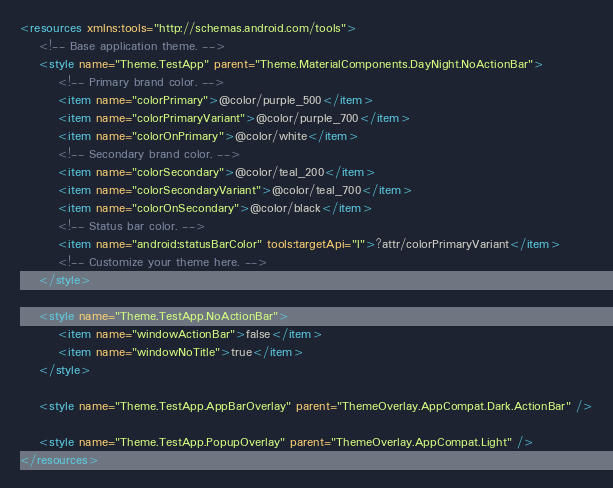<code> <loc_0><loc_0><loc_500><loc_500><_XML_><resources xmlns:tools="http://schemas.android.com/tools">
    <!-- Base application theme. -->
    <style name="Theme.TestApp" parent="Theme.MaterialComponents.DayNight.NoActionBar">
        <!-- Primary brand color. -->
        <item name="colorPrimary">@color/purple_500</item>
        <item name="colorPrimaryVariant">@color/purple_700</item>
        <item name="colorOnPrimary">@color/white</item>
        <!-- Secondary brand color. -->
        <item name="colorSecondary">@color/teal_200</item>
        <item name="colorSecondaryVariant">@color/teal_700</item>
        <item name="colorOnSecondary">@color/black</item>
        <!-- Status bar color. -->
        <item name="android:statusBarColor" tools:targetApi="l">?attr/colorPrimaryVariant</item>
        <!-- Customize your theme here. -->
    </style>

    <style name="Theme.TestApp.NoActionBar">
        <item name="windowActionBar">false</item>
        <item name="windowNoTitle">true</item>
    </style>

    <style name="Theme.TestApp.AppBarOverlay" parent="ThemeOverlay.AppCompat.Dark.ActionBar" />

    <style name="Theme.TestApp.PopupOverlay" parent="ThemeOverlay.AppCompat.Light" />
</resources></code> 